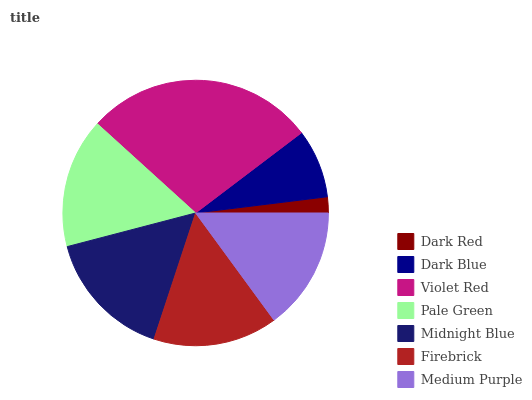Is Dark Red the minimum?
Answer yes or no. Yes. Is Violet Red the maximum?
Answer yes or no. Yes. Is Dark Blue the minimum?
Answer yes or no. No. Is Dark Blue the maximum?
Answer yes or no. No. Is Dark Blue greater than Dark Red?
Answer yes or no. Yes. Is Dark Red less than Dark Blue?
Answer yes or no. Yes. Is Dark Red greater than Dark Blue?
Answer yes or no. No. Is Dark Blue less than Dark Red?
Answer yes or no. No. Is Firebrick the high median?
Answer yes or no. Yes. Is Firebrick the low median?
Answer yes or no. Yes. Is Violet Red the high median?
Answer yes or no. No. Is Medium Purple the low median?
Answer yes or no. No. 